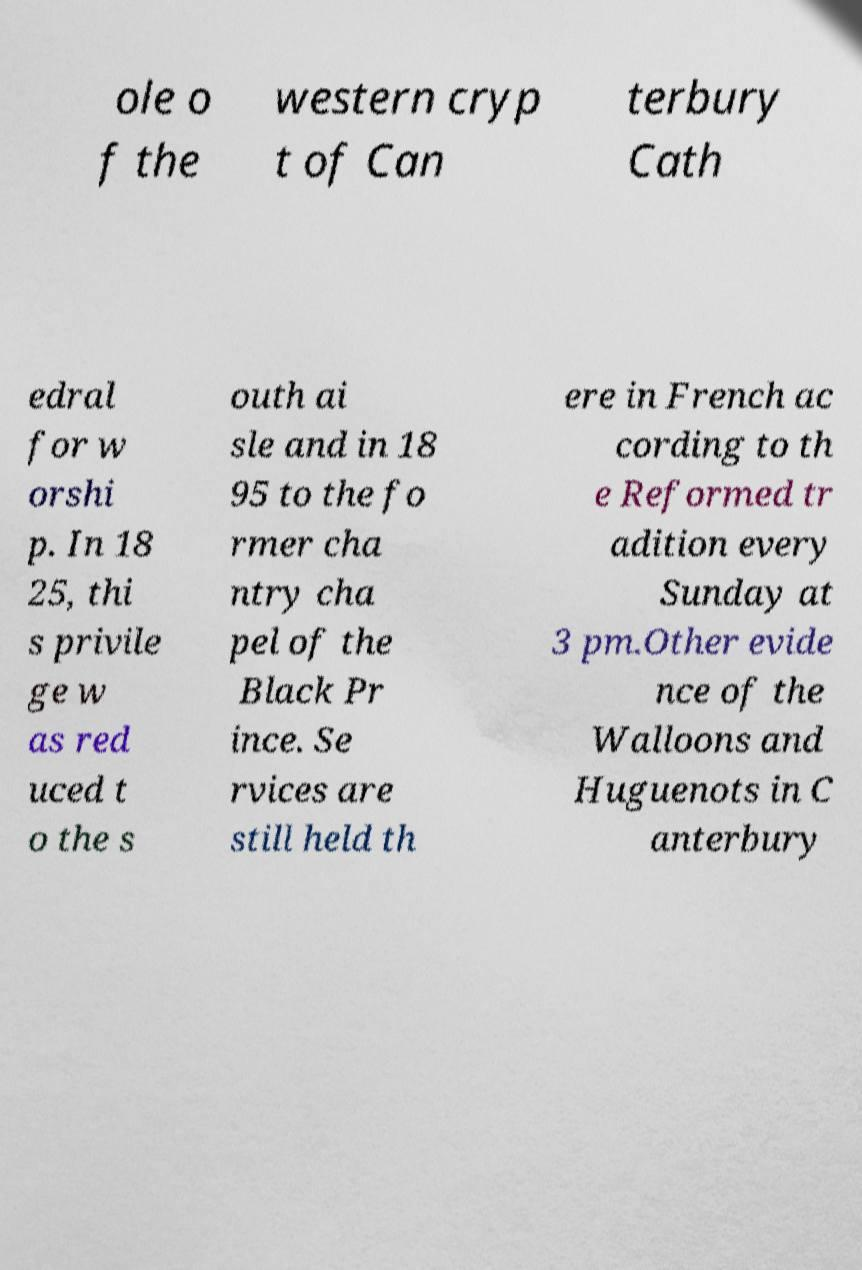Could you assist in decoding the text presented in this image and type it out clearly? ole o f the western cryp t of Can terbury Cath edral for w orshi p. In 18 25, thi s privile ge w as red uced t o the s outh ai sle and in 18 95 to the fo rmer cha ntry cha pel of the Black Pr ince. Se rvices are still held th ere in French ac cording to th e Reformed tr adition every Sunday at 3 pm.Other evide nce of the Walloons and Huguenots in C anterbury 